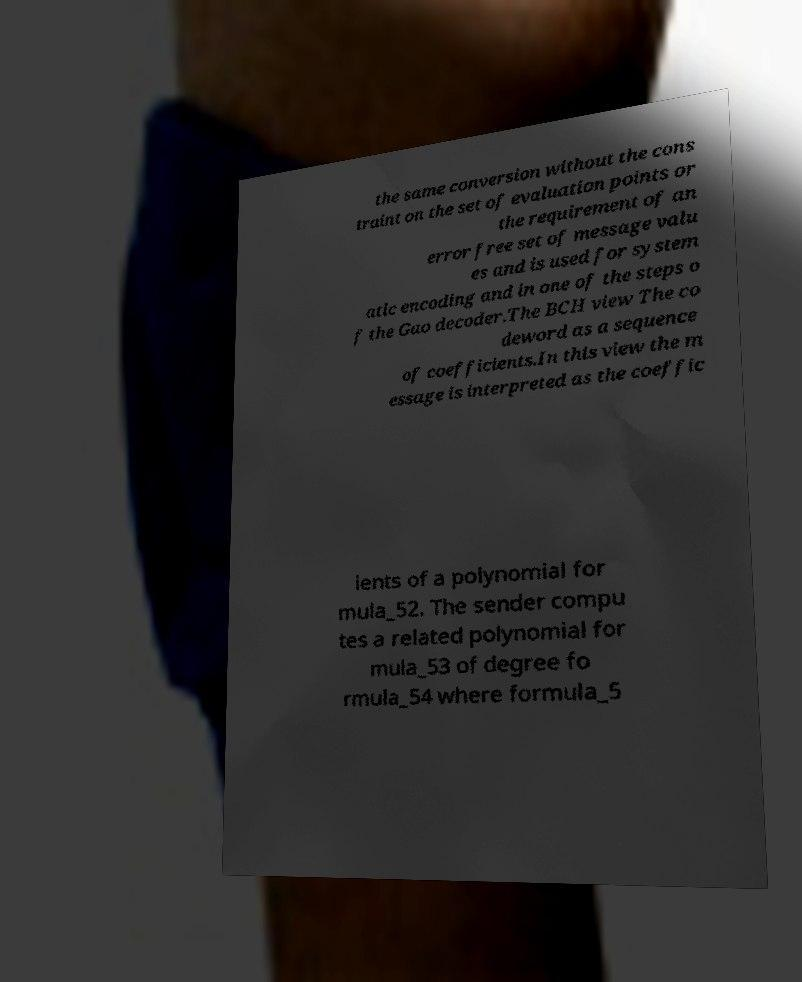Can you accurately transcribe the text from the provided image for me? the same conversion without the cons traint on the set of evaluation points or the requirement of an error free set of message valu es and is used for system atic encoding and in one of the steps o f the Gao decoder.The BCH view The co deword as a sequence of coefficients.In this view the m essage is interpreted as the coeffic ients of a polynomial for mula_52. The sender compu tes a related polynomial for mula_53 of degree fo rmula_54 where formula_5 